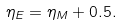Convert formula to latex. <formula><loc_0><loc_0><loc_500><loc_500>\eta _ { E } = \eta _ { M } + 0 . 5 .</formula> 